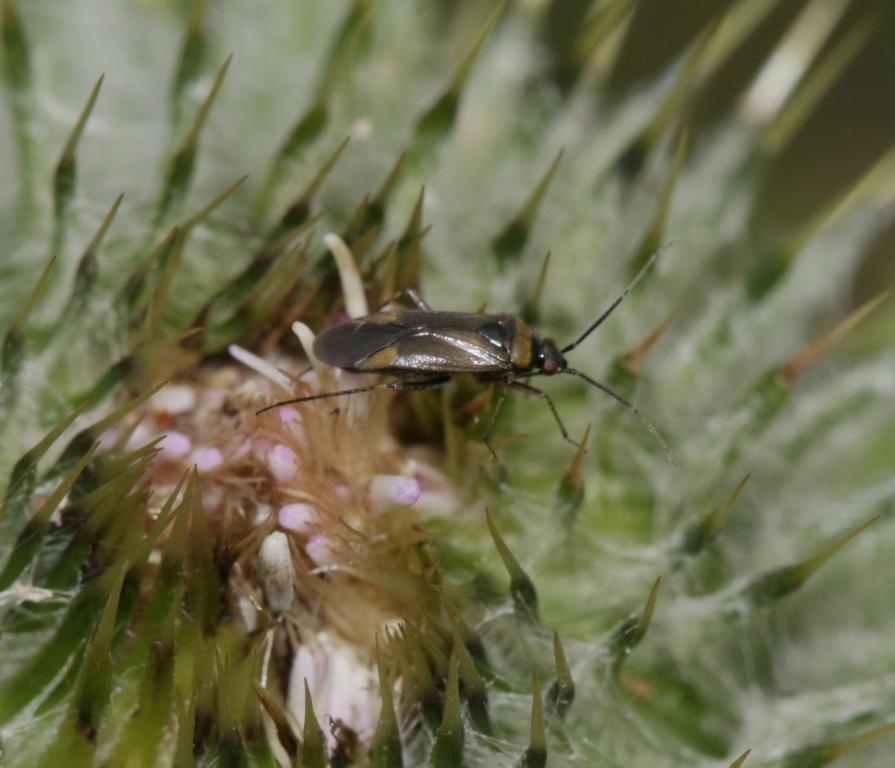What is present in the image? There is an insect in the image. Where is the insect located? The insect is on a flower. What type of detail can be seen on the star in the image? There is no star present in the image; it features an insect on a flower. 